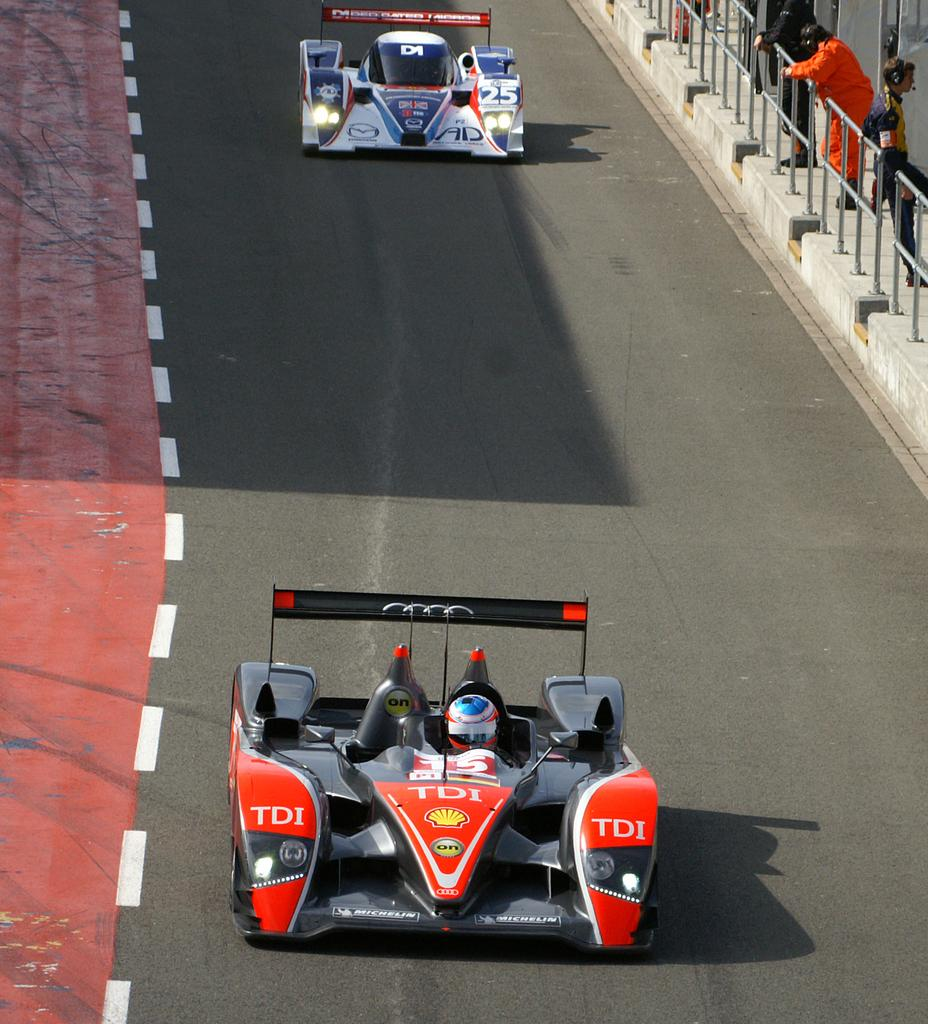What can be seen on the road in the image? There are two cars on the road in the image. Is there anyone inside the cars? Yes, there is a person in one of the cars. What else can be seen on the right side of the image? There are three persons on the right side of the image. What type of structure is visible in the image? There is railing visible in the image. What color are the eyes of the boys in the image? There are no boys present in the image, and therefore no eyes to describe. 